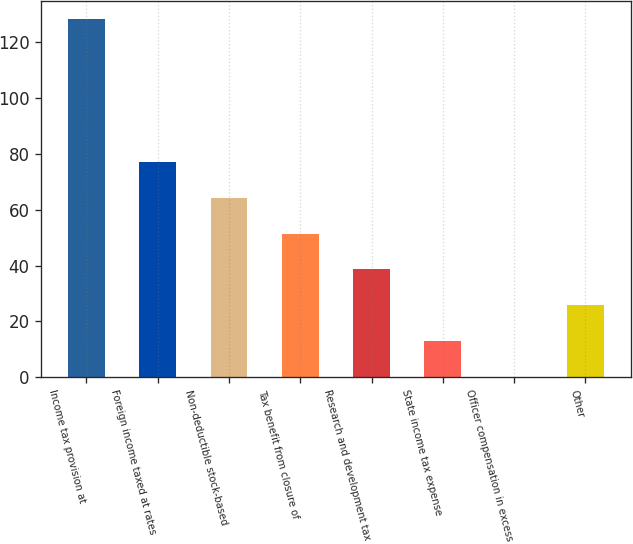Convert chart to OTSL. <chart><loc_0><loc_0><loc_500><loc_500><bar_chart><fcel>Income tax provision at<fcel>Foreign income taxed at rates<fcel>Non-deductible stock-based<fcel>Tax benefit from closure of<fcel>Research and development tax<fcel>State income tax expense<fcel>Officer compensation in excess<fcel>Other<nl><fcel>128.3<fcel>77.06<fcel>64.25<fcel>51.44<fcel>38.63<fcel>13.01<fcel>0.2<fcel>25.82<nl></chart> 